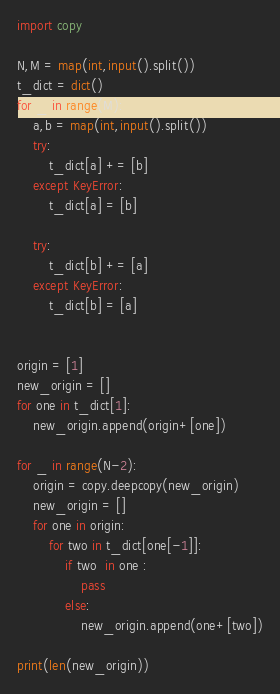<code> <loc_0><loc_0><loc_500><loc_500><_Python_>import copy

N,M = map(int,input().split())
t_dict = dict()
for _ in range(M):
    a,b = map(int,input().split())
    try:
        t_dict[a] += [b]
    except KeyError:
        t_dict[a] = [b]
        
    try:
        t_dict[b] += [a]
    except KeyError:
        t_dict[b] = [a]
        

origin = [1]
new_origin = []
for one in t_dict[1]:
    new_origin.append(origin+[one])

for _ in range(N-2):
    origin = copy.deepcopy(new_origin)
    new_origin = []
    for one in origin:
        for two in t_dict[one[-1]]:
            if two  in one :
                pass
            else:
                new_origin.append(one+[two])
                
print(len(new_origin))</code> 